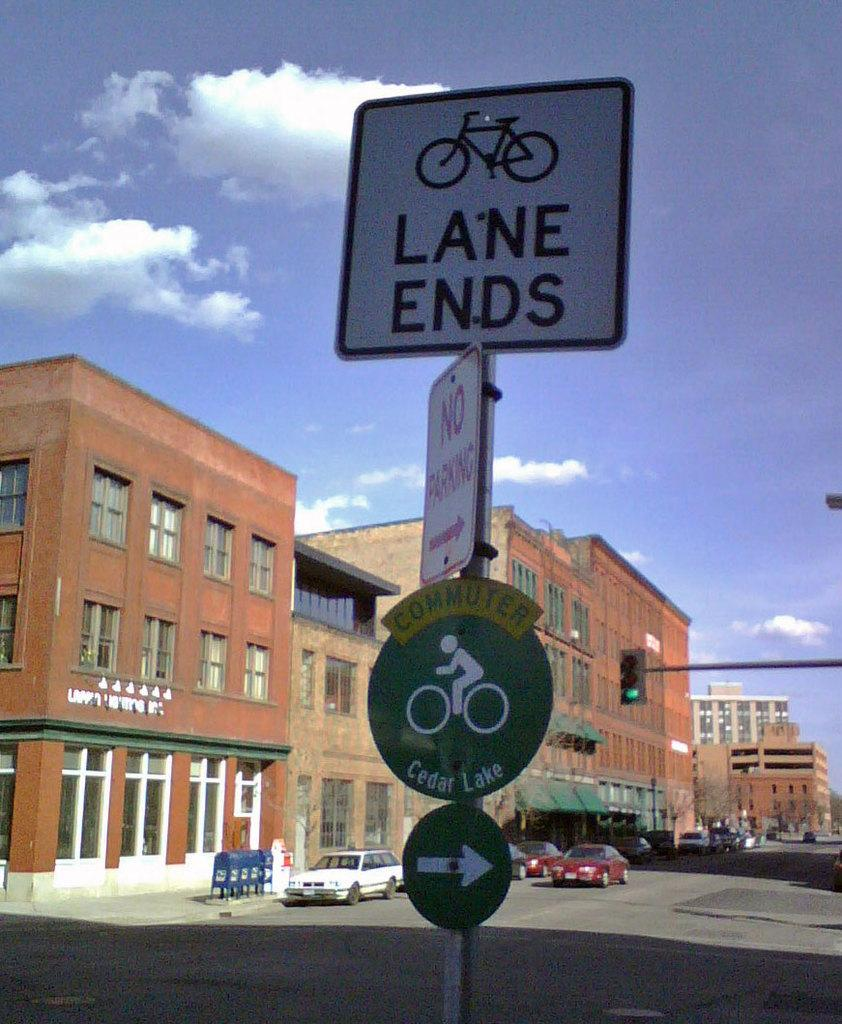<image>
Relay a brief, clear account of the picture shown. The bicycle lane ends but there is another one to the right that goes to Cedar Lake. 